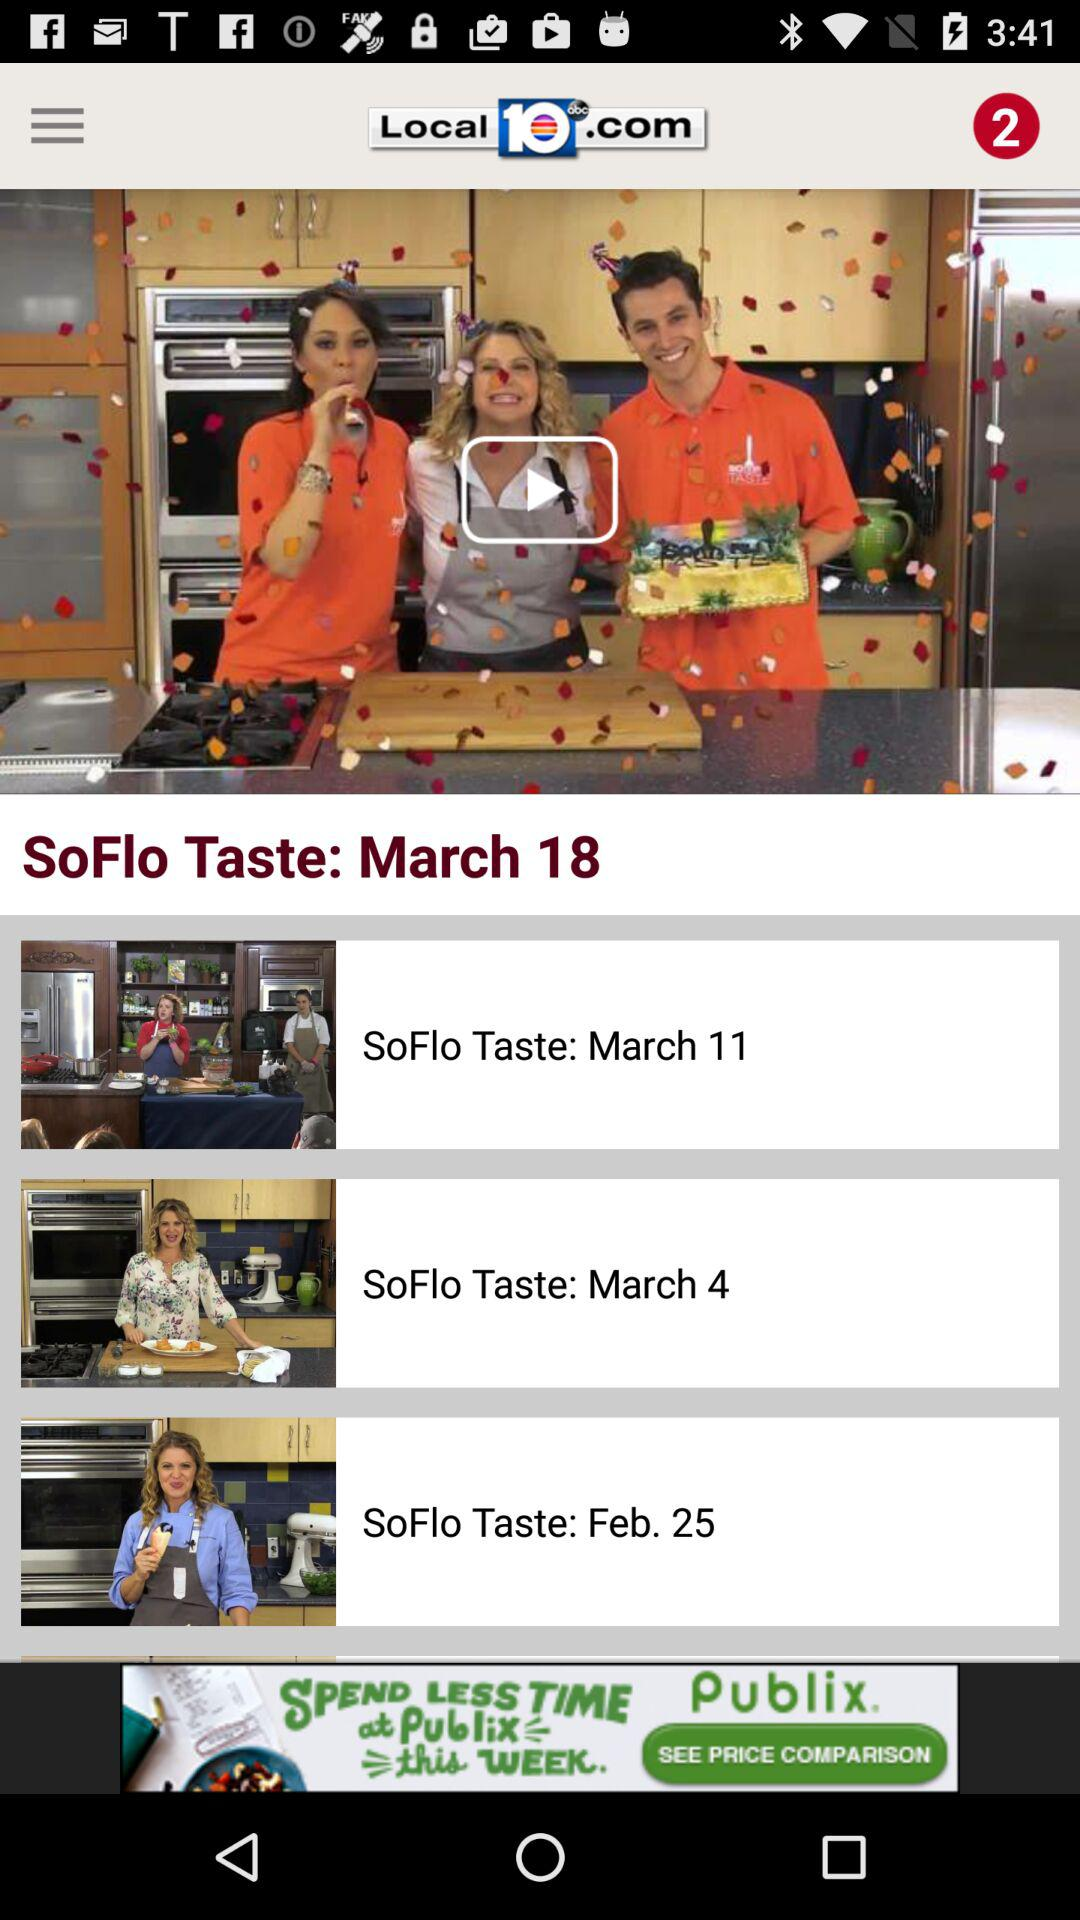What is the name of the application? The name of the application is "Local 10 - WPLG Miami". 